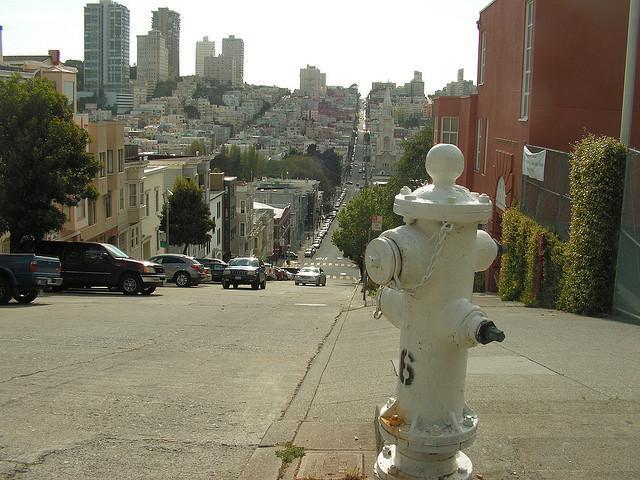How many trucks are there?
Give a very brief answer. 2. How many cars are in the photo?
Give a very brief answer. 2. How many people are holding a letter?
Give a very brief answer. 0. 